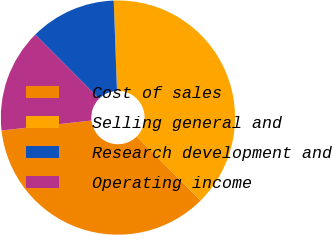<chart> <loc_0><loc_0><loc_500><loc_500><pie_chart><fcel>Cost of sales<fcel>Selling general and<fcel>Research development and<fcel>Operating income<nl><fcel>35.71%<fcel>38.1%<fcel>11.9%<fcel>14.29%<nl></chart> 